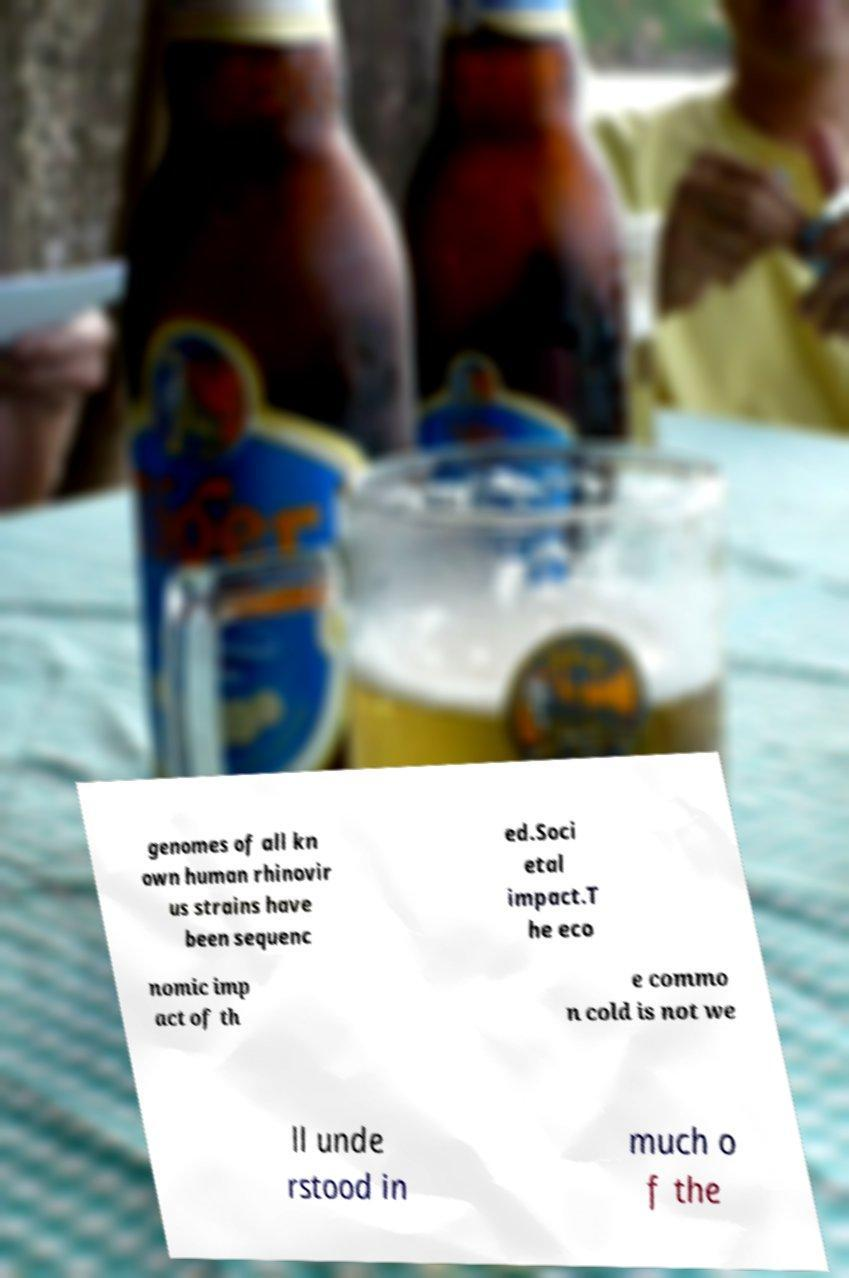What messages or text are displayed in this image? I need them in a readable, typed format. genomes of all kn own human rhinovir us strains have been sequenc ed.Soci etal impact.T he eco nomic imp act of th e commo n cold is not we ll unde rstood in much o f the 